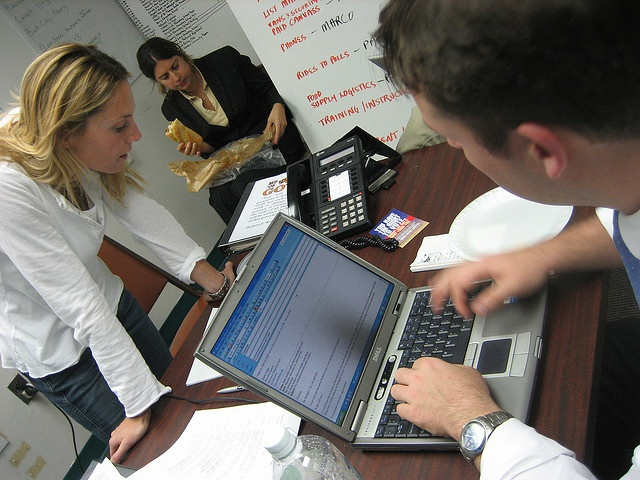Describe the objects in this image and their specific colors. I can see people in gray, black, tan, and white tones, people in gray, darkgray, lightgray, and black tones, laptop in gray, darkgray, and black tones, people in gray, black, maroon, and tan tones, and bottle in gray, darkgray, and lightgray tones in this image. 